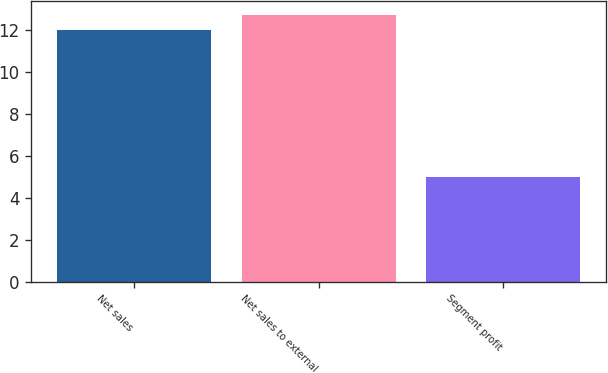<chart> <loc_0><loc_0><loc_500><loc_500><bar_chart><fcel>Net sales<fcel>Net sales to external<fcel>Segment profit<nl><fcel>12<fcel>12.7<fcel>5<nl></chart> 